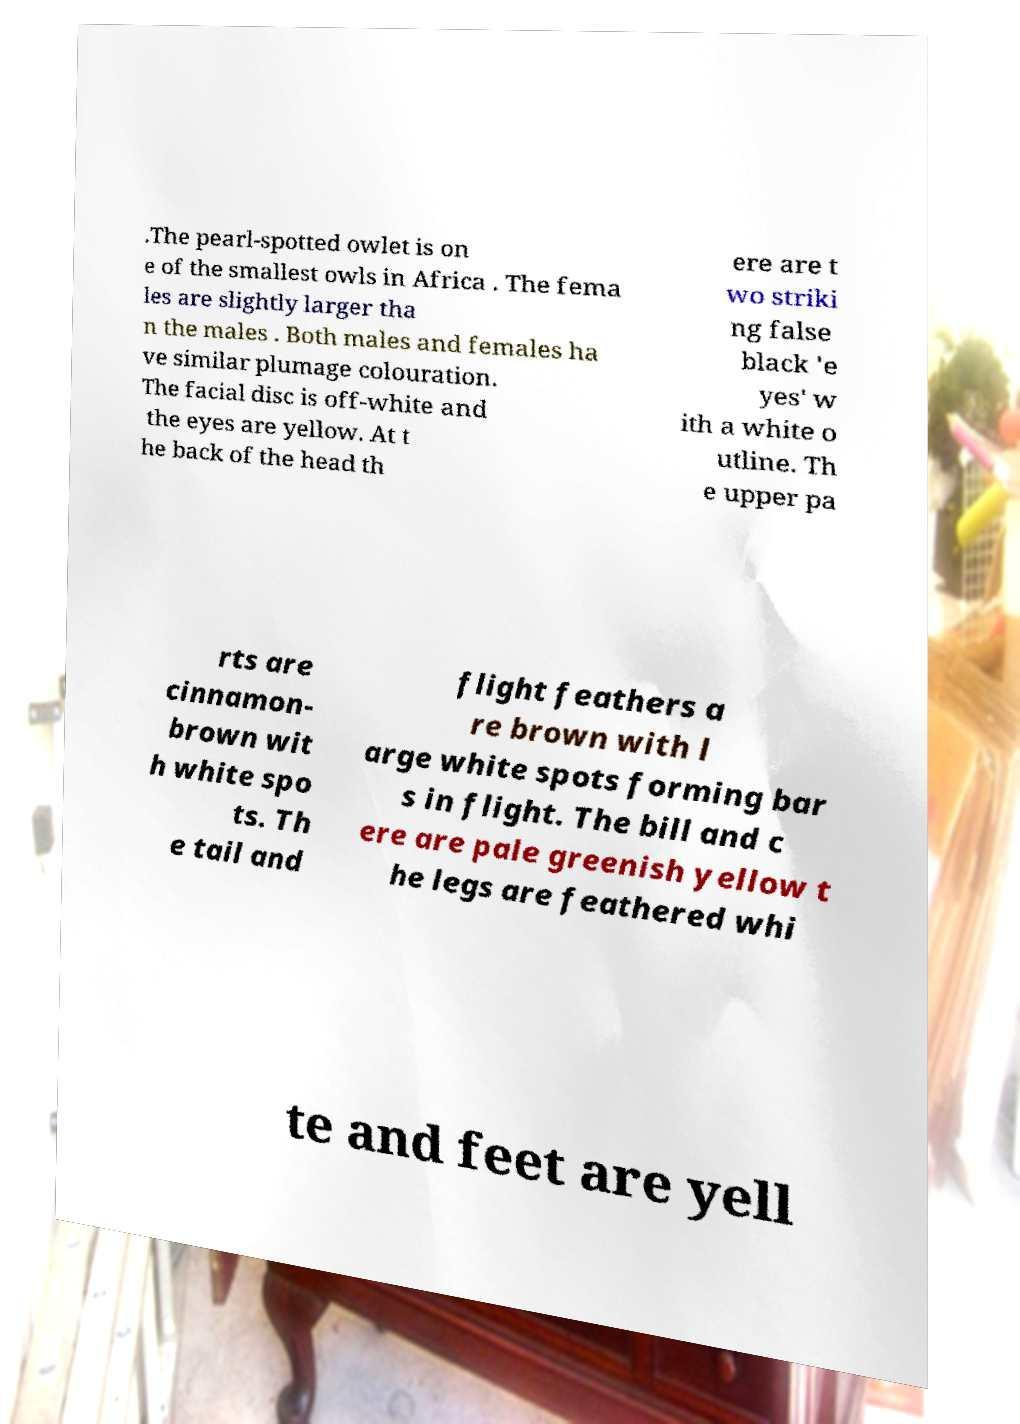Could you extract and type out the text from this image? .The pearl-spotted owlet is on e of the smallest owls in Africa . The fema les are slightly larger tha n the males . Both males and females ha ve similar plumage colouration. The facial disc is off-white and the eyes are yellow. At t he back of the head th ere are t wo striki ng false black 'e yes' w ith a white o utline. Th e upper pa rts are cinnamon- brown wit h white spo ts. Th e tail and flight feathers a re brown with l arge white spots forming bar s in flight. The bill and c ere are pale greenish yellow t he legs are feathered whi te and feet are yell 